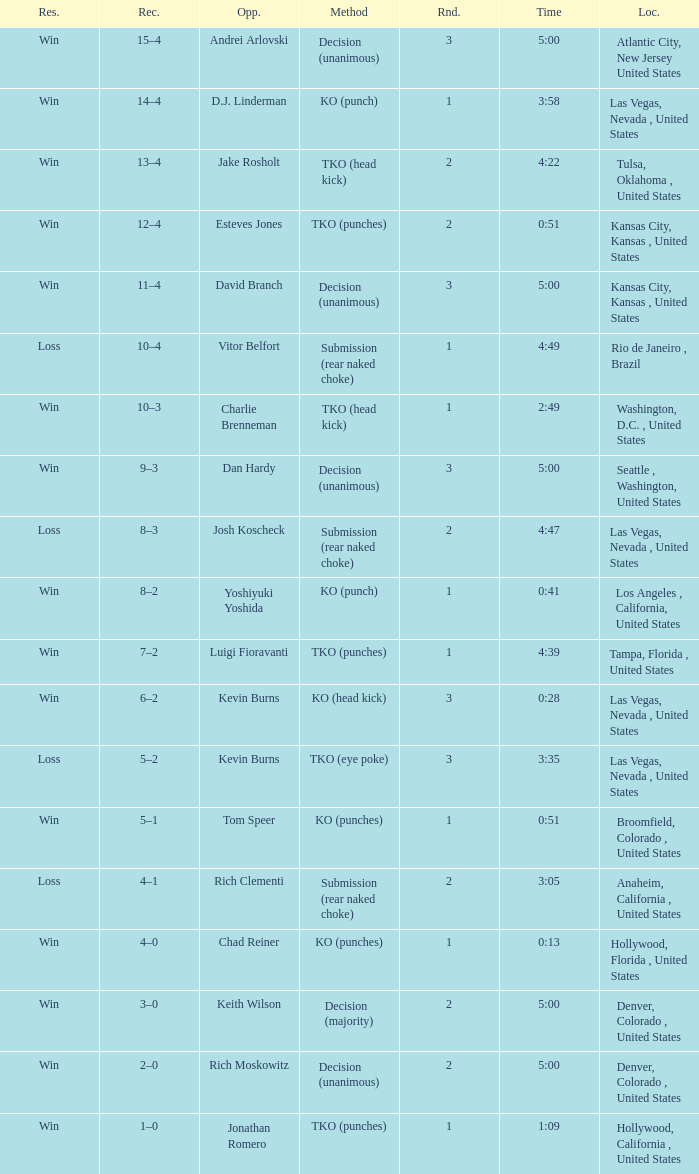What is the highest round number with a time of 4:39? 1.0. 